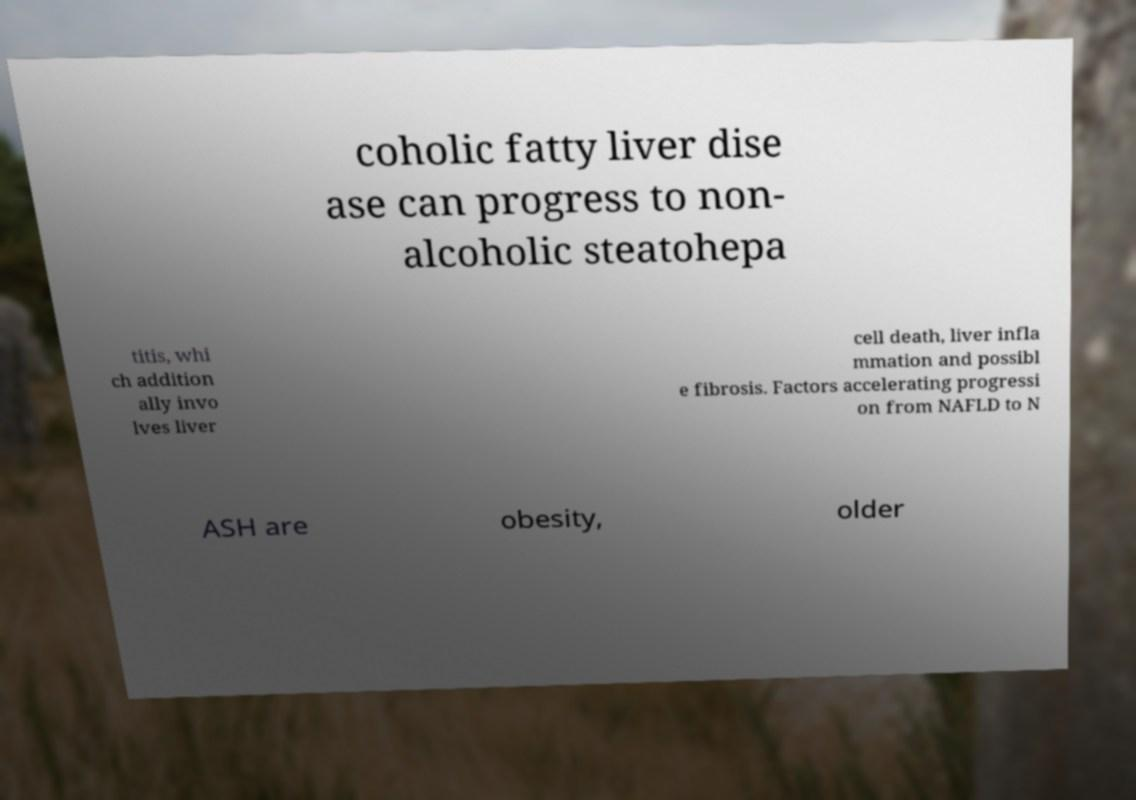Please identify and transcribe the text found in this image. coholic fatty liver dise ase can progress to non- alcoholic steatohepa titis, whi ch addition ally invo lves liver cell death, liver infla mmation and possibl e fibrosis. Factors accelerating progressi on from NAFLD to N ASH are obesity, older 